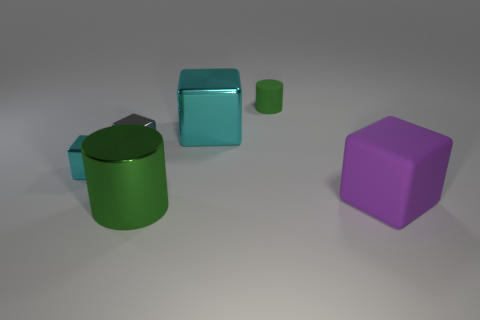Subtract all brown balls. How many cyan cubes are left? 2 Subtract all small gray cubes. How many cubes are left? 3 Add 3 small yellow metallic balls. How many objects exist? 9 Subtract all gray blocks. How many blocks are left? 3 Subtract all yellow cubes. Subtract all gray cylinders. How many cubes are left? 4 Subtract all cubes. How many objects are left? 2 Subtract all big cyan shiny blocks. Subtract all cyan objects. How many objects are left? 3 Add 5 large cyan metallic blocks. How many large cyan metallic blocks are left? 6 Add 3 brown matte cylinders. How many brown matte cylinders exist? 3 Subtract 0 red spheres. How many objects are left? 6 